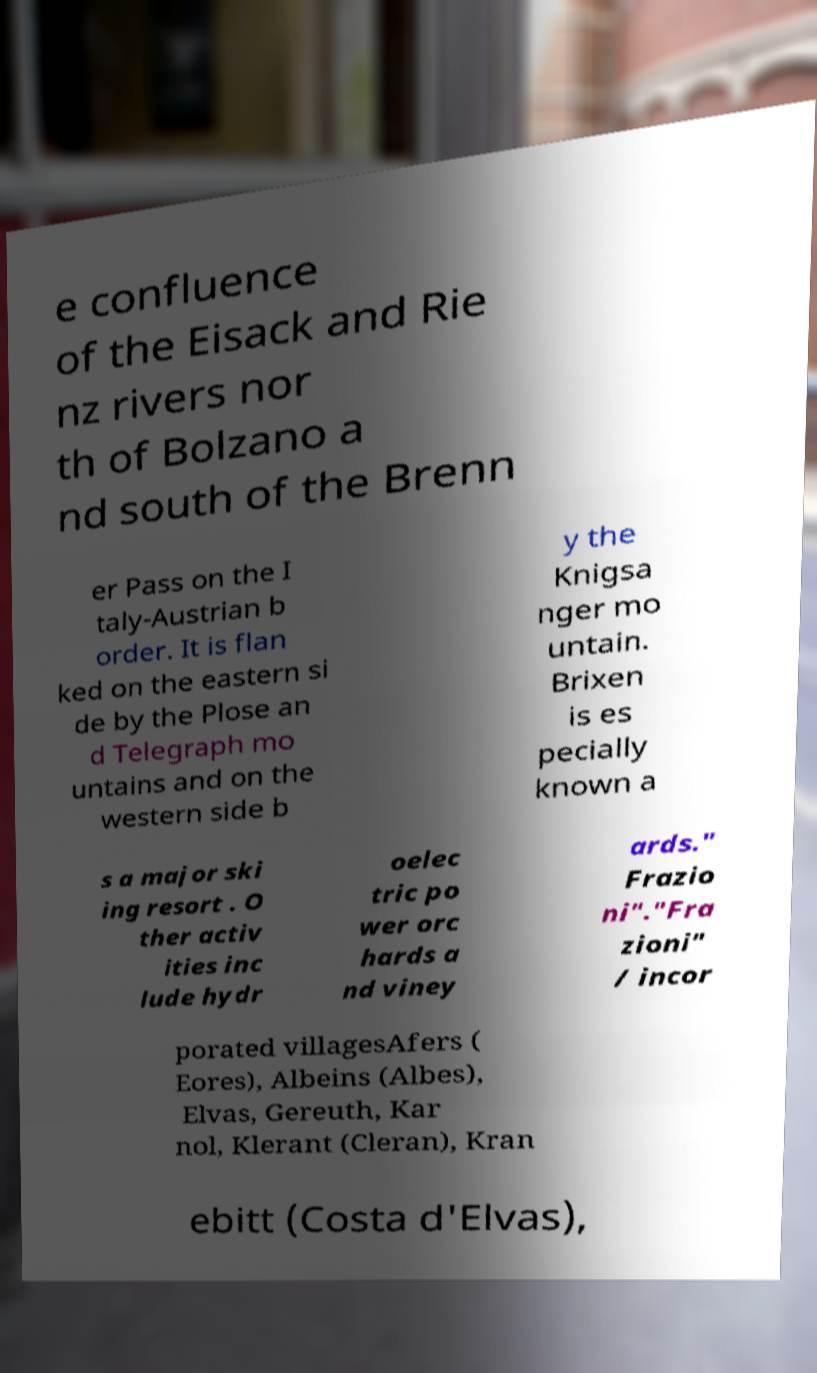Can you read and provide the text displayed in the image?This photo seems to have some interesting text. Can you extract and type it out for me? e confluence of the Eisack and Rie nz rivers nor th of Bolzano a nd south of the Brenn er Pass on the I taly-Austrian b order. It is flan ked on the eastern si de by the Plose an d Telegraph mo untains and on the western side b y the Knigsa nger mo untain. Brixen is es pecially known a s a major ski ing resort . O ther activ ities inc lude hydr oelec tric po wer orc hards a nd viney ards." Frazio ni"."Fra zioni" / incor porated villagesAfers ( Eores), Albeins (Albes), Elvas, Gereuth, Kar nol, Klerant (Cleran), Kran ebitt (Costa d'Elvas), 